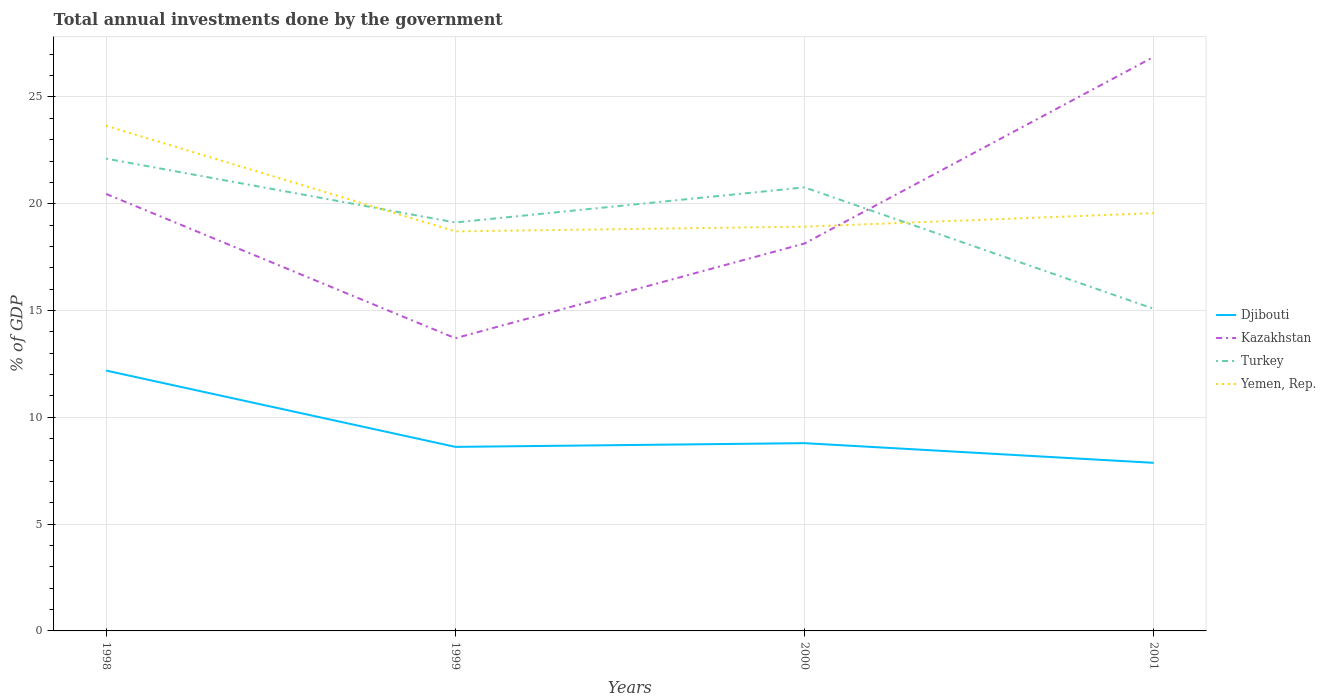How many different coloured lines are there?
Provide a short and direct response. 4. Does the line corresponding to Kazakhstan intersect with the line corresponding to Djibouti?
Your answer should be compact. No. Across all years, what is the maximum total annual investments done by the government in Yemen, Rep.?
Offer a terse response. 18.71. In which year was the total annual investments done by the government in Kazakhstan maximum?
Your answer should be very brief. 1999. What is the total total annual investments done by the government in Turkey in the graph?
Keep it short and to the point. 1.35. What is the difference between the highest and the second highest total annual investments done by the government in Yemen, Rep.?
Your answer should be very brief. 4.94. How many years are there in the graph?
Offer a terse response. 4. Are the values on the major ticks of Y-axis written in scientific E-notation?
Offer a terse response. No. How many legend labels are there?
Ensure brevity in your answer.  4. What is the title of the graph?
Ensure brevity in your answer.  Total annual investments done by the government. Does "Saudi Arabia" appear as one of the legend labels in the graph?
Your answer should be compact. No. What is the label or title of the Y-axis?
Offer a terse response. % of GDP. What is the % of GDP in Djibouti in 1998?
Provide a succinct answer. 12.19. What is the % of GDP in Kazakhstan in 1998?
Your answer should be compact. 20.46. What is the % of GDP of Turkey in 1998?
Your answer should be very brief. 22.11. What is the % of GDP in Yemen, Rep. in 1998?
Ensure brevity in your answer.  23.65. What is the % of GDP of Djibouti in 1999?
Keep it short and to the point. 8.62. What is the % of GDP of Kazakhstan in 1999?
Your response must be concise. 13.7. What is the % of GDP of Turkey in 1999?
Give a very brief answer. 19.12. What is the % of GDP in Yemen, Rep. in 1999?
Ensure brevity in your answer.  18.71. What is the % of GDP in Djibouti in 2000?
Ensure brevity in your answer.  8.79. What is the % of GDP in Kazakhstan in 2000?
Keep it short and to the point. 18.14. What is the % of GDP in Turkey in 2000?
Offer a terse response. 20.77. What is the % of GDP in Yemen, Rep. in 2000?
Give a very brief answer. 18.93. What is the % of GDP of Djibouti in 2001?
Offer a terse response. 7.87. What is the % of GDP in Kazakhstan in 2001?
Keep it short and to the point. 26.88. What is the % of GDP of Turkey in 2001?
Keep it short and to the point. 15.08. What is the % of GDP of Yemen, Rep. in 2001?
Provide a short and direct response. 19.56. Across all years, what is the maximum % of GDP of Djibouti?
Ensure brevity in your answer.  12.19. Across all years, what is the maximum % of GDP of Kazakhstan?
Offer a very short reply. 26.88. Across all years, what is the maximum % of GDP of Turkey?
Offer a very short reply. 22.11. Across all years, what is the maximum % of GDP in Yemen, Rep.?
Provide a succinct answer. 23.65. Across all years, what is the minimum % of GDP of Djibouti?
Keep it short and to the point. 7.87. Across all years, what is the minimum % of GDP of Kazakhstan?
Offer a very short reply. 13.7. Across all years, what is the minimum % of GDP in Turkey?
Your answer should be very brief. 15.08. Across all years, what is the minimum % of GDP of Yemen, Rep.?
Give a very brief answer. 18.71. What is the total % of GDP of Djibouti in the graph?
Ensure brevity in your answer.  37.47. What is the total % of GDP in Kazakhstan in the graph?
Offer a very short reply. 79.18. What is the total % of GDP in Turkey in the graph?
Ensure brevity in your answer.  77.09. What is the total % of GDP in Yemen, Rep. in the graph?
Provide a succinct answer. 80.84. What is the difference between the % of GDP in Djibouti in 1998 and that in 1999?
Keep it short and to the point. 3.57. What is the difference between the % of GDP of Kazakhstan in 1998 and that in 1999?
Ensure brevity in your answer.  6.76. What is the difference between the % of GDP of Turkey in 1998 and that in 1999?
Your answer should be compact. 2.99. What is the difference between the % of GDP in Yemen, Rep. in 1998 and that in 1999?
Provide a short and direct response. 4.94. What is the difference between the % of GDP in Djibouti in 1998 and that in 2000?
Your answer should be very brief. 3.4. What is the difference between the % of GDP in Kazakhstan in 1998 and that in 2000?
Provide a short and direct response. 2.32. What is the difference between the % of GDP in Turkey in 1998 and that in 2000?
Provide a succinct answer. 1.35. What is the difference between the % of GDP in Yemen, Rep. in 1998 and that in 2000?
Your response must be concise. 4.72. What is the difference between the % of GDP of Djibouti in 1998 and that in 2001?
Your response must be concise. 4.32. What is the difference between the % of GDP of Kazakhstan in 1998 and that in 2001?
Your answer should be compact. -6.42. What is the difference between the % of GDP in Turkey in 1998 and that in 2001?
Your answer should be compact. 7.03. What is the difference between the % of GDP of Yemen, Rep. in 1998 and that in 2001?
Provide a succinct answer. 4.09. What is the difference between the % of GDP in Djibouti in 1999 and that in 2000?
Offer a very short reply. -0.17. What is the difference between the % of GDP of Kazakhstan in 1999 and that in 2000?
Your answer should be very brief. -4.43. What is the difference between the % of GDP in Turkey in 1999 and that in 2000?
Your answer should be compact. -1.64. What is the difference between the % of GDP of Yemen, Rep. in 1999 and that in 2000?
Keep it short and to the point. -0.22. What is the difference between the % of GDP in Djibouti in 1999 and that in 2001?
Your response must be concise. 0.75. What is the difference between the % of GDP in Kazakhstan in 1999 and that in 2001?
Your answer should be very brief. -13.17. What is the difference between the % of GDP of Turkey in 1999 and that in 2001?
Provide a short and direct response. 4.04. What is the difference between the % of GDP of Yemen, Rep. in 1999 and that in 2001?
Your answer should be compact. -0.85. What is the difference between the % of GDP of Djibouti in 2000 and that in 2001?
Provide a succinct answer. 0.92. What is the difference between the % of GDP of Kazakhstan in 2000 and that in 2001?
Your response must be concise. -8.74. What is the difference between the % of GDP of Turkey in 2000 and that in 2001?
Keep it short and to the point. 5.68. What is the difference between the % of GDP of Yemen, Rep. in 2000 and that in 2001?
Give a very brief answer. -0.63. What is the difference between the % of GDP in Djibouti in 1998 and the % of GDP in Kazakhstan in 1999?
Provide a succinct answer. -1.51. What is the difference between the % of GDP of Djibouti in 1998 and the % of GDP of Turkey in 1999?
Your answer should be very brief. -6.93. What is the difference between the % of GDP of Djibouti in 1998 and the % of GDP of Yemen, Rep. in 1999?
Provide a short and direct response. -6.52. What is the difference between the % of GDP of Kazakhstan in 1998 and the % of GDP of Turkey in 1999?
Provide a short and direct response. 1.34. What is the difference between the % of GDP of Kazakhstan in 1998 and the % of GDP of Yemen, Rep. in 1999?
Your response must be concise. 1.75. What is the difference between the % of GDP in Turkey in 1998 and the % of GDP in Yemen, Rep. in 1999?
Make the answer very short. 3.41. What is the difference between the % of GDP of Djibouti in 1998 and the % of GDP of Kazakhstan in 2000?
Offer a very short reply. -5.95. What is the difference between the % of GDP of Djibouti in 1998 and the % of GDP of Turkey in 2000?
Your response must be concise. -8.58. What is the difference between the % of GDP of Djibouti in 1998 and the % of GDP of Yemen, Rep. in 2000?
Your response must be concise. -6.74. What is the difference between the % of GDP in Kazakhstan in 1998 and the % of GDP in Turkey in 2000?
Provide a short and direct response. -0.31. What is the difference between the % of GDP in Kazakhstan in 1998 and the % of GDP in Yemen, Rep. in 2000?
Your response must be concise. 1.53. What is the difference between the % of GDP of Turkey in 1998 and the % of GDP of Yemen, Rep. in 2000?
Make the answer very short. 3.19. What is the difference between the % of GDP in Djibouti in 1998 and the % of GDP in Kazakhstan in 2001?
Your answer should be compact. -14.69. What is the difference between the % of GDP in Djibouti in 1998 and the % of GDP in Turkey in 2001?
Provide a short and direct response. -2.89. What is the difference between the % of GDP in Djibouti in 1998 and the % of GDP in Yemen, Rep. in 2001?
Offer a terse response. -7.37. What is the difference between the % of GDP of Kazakhstan in 1998 and the % of GDP of Turkey in 2001?
Your response must be concise. 5.38. What is the difference between the % of GDP in Kazakhstan in 1998 and the % of GDP in Yemen, Rep. in 2001?
Provide a short and direct response. 0.9. What is the difference between the % of GDP in Turkey in 1998 and the % of GDP in Yemen, Rep. in 2001?
Offer a very short reply. 2.55. What is the difference between the % of GDP of Djibouti in 1999 and the % of GDP of Kazakhstan in 2000?
Provide a succinct answer. -9.52. What is the difference between the % of GDP of Djibouti in 1999 and the % of GDP of Turkey in 2000?
Your answer should be compact. -12.15. What is the difference between the % of GDP in Djibouti in 1999 and the % of GDP in Yemen, Rep. in 2000?
Offer a very short reply. -10.31. What is the difference between the % of GDP in Kazakhstan in 1999 and the % of GDP in Turkey in 2000?
Offer a terse response. -7.06. What is the difference between the % of GDP of Kazakhstan in 1999 and the % of GDP of Yemen, Rep. in 2000?
Ensure brevity in your answer.  -5.22. What is the difference between the % of GDP of Turkey in 1999 and the % of GDP of Yemen, Rep. in 2000?
Your response must be concise. 0.2. What is the difference between the % of GDP of Djibouti in 1999 and the % of GDP of Kazakhstan in 2001?
Your answer should be compact. -18.26. What is the difference between the % of GDP of Djibouti in 1999 and the % of GDP of Turkey in 2001?
Make the answer very short. -6.47. What is the difference between the % of GDP in Djibouti in 1999 and the % of GDP in Yemen, Rep. in 2001?
Provide a short and direct response. -10.94. What is the difference between the % of GDP of Kazakhstan in 1999 and the % of GDP of Turkey in 2001?
Give a very brief answer. -1.38. What is the difference between the % of GDP in Kazakhstan in 1999 and the % of GDP in Yemen, Rep. in 2001?
Keep it short and to the point. -5.86. What is the difference between the % of GDP in Turkey in 1999 and the % of GDP in Yemen, Rep. in 2001?
Your response must be concise. -0.44. What is the difference between the % of GDP of Djibouti in 2000 and the % of GDP of Kazakhstan in 2001?
Ensure brevity in your answer.  -18.09. What is the difference between the % of GDP of Djibouti in 2000 and the % of GDP of Turkey in 2001?
Your answer should be compact. -6.29. What is the difference between the % of GDP of Djibouti in 2000 and the % of GDP of Yemen, Rep. in 2001?
Make the answer very short. -10.77. What is the difference between the % of GDP of Kazakhstan in 2000 and the % of GDP of Turkey in 2001?
Offer a very short reply. 3.06. What is the difference between the % of GDP of Kazakhstan in 2000 and the % of GDP of Yemen, Rep. in 2001?
Give a very brief answer. -1.42. What is the difference between the % of GDP in Turkey in 2000 and the % of GDP in Yemen, Rep. in 2001?
Give a very brief answer. 1.21. What is the average % of GDP of Djibouti per year?
Offer a terse response. 9.37. What is the average % of GDP of Kazakhstan per year?
Make the answer very short. 19.8. What is the average % of GDP of Turkey per year?
Provide a succinct answer. 19.27. What is the average % of GDP in Yemen, Rep. per year?
Offer a terse response. 20.21. In the year 1998, what is the difference between the % of GDP of Djibouti and % of GDP of Kazakhstan?
Your answer should be compact. -8.27. In the year 1998, what is the difference between the % of GDP of Djibouti and % of GDP of Turkey?
Your response must be concise. -9.92. In the year 1998, what is the difference between the % of GDP of Djibouti and % of GDP of Yemen, Rep.?
Offer a terse response. -11.46. In the year 1998, what is the difference between the % of GDP in Kazakhstan and % of GDP in Turkey?
Ensure brevity in your answer.  -1.65. In the year 1998, what is the difference between the % of GDP in Kazakhstan and % of GDP in Yemen, Rep.?
Keep it short and to the point. -3.19. In the year 1998, what is the difference between the % of GDP in Turkey and % of GDP in Yemen, Rep.?
Offer a terse response. -1.54. In the year 1999, what is the difference between the % of GDP in Djibouti and % of GDP in Kazakhstan?
Provide a succinct answer. -5.09. In the year 1999, what is the difference between the % of GDP in Djibouti and % of GDP in Turkey?
Make the answer very short. -10.51. In the year 1999, what is the difference between the % of GDP in Djibouti and % of GDP in Yemen, Rep.?
Provide a succinct answer. -10.09. In the year 1999, what is the difference between the % of GDP in Kazakhstan and % of GDP in Turkey?
Make the answer very short. -5.42. In the year 1999, what is the difference between the % of GDP in Kazakhstan and % of GDP in Yemen, Rep.?
Your response must be concise. -5. In the year 1999, what is the difference between the % of GDP of Turkey and % of GDP of Yemen, Rep.?
Ensure brevity in your answer.  0.42. In the year 2000, what is the difference between the % of GDP in Djibouti and % of GDP in Kazakhstan?
Ensure brevity in your answer.  -9.35. In the year 2000, what is the difference between the % of GDP of Djibouti and % of GDP of Turkey?
Offer a very short reply. -11.98. In the year 2000, what is the difference between the % of GDP of Djibouti and % of GDP of Yemen, Rep.?
Give a very brief answer. -10.14. In the year 2000, what is the difference between the % of GDP in Kazakhstan and % of GDP in Turkey?
Provide a short and direct response. -2.63. In the year 2000, what is the difference between the % of GDP in Kazakhstan and % of GDP in Yemen, Rep.?
Give a very brief answer. -0.79. In the year 2000, what is the difference between the % of GDP of Turkey and % of GDP of Yemen, Rep.?
Offer a terse response. 1.84. In the year 2001, what is the difference between the % of GDP in Djibouti and % of GDP in Kazakhstan?
Give a very brief answer. -19.01. In the year 2001, what is the difference between the % of GDP in Djibouti and % of GDP in Turkey?
Your response must be concise. -7.21. In the year 2001, what is the difference between the % of GDP of Djibouti and % of GDP of Yemen, Rep.?
Offer a very short reply. -11.69. In the year 2001, what is the difference between the % of GDP in Kazakhstan and % of GDP in Turkey?
Ensure brevity in your answer.  11.79. In the year 2001, what is the difference between the % of GDP of Kazakhstan and % of GDP of Yemen, Rep.?
Offer a terse response. 7.32. In the year 2001, what is the difference between the % of GDP in Turkey and % of GDP in Yemen, Rep.?
Offer a very short reply. -4.48. What is the ratio of the % of GDP of Djibouti in 1998 to that in 1999?
Your response must be concise. 1.41. What is the ratio of the % of GDP of Kazakhstan in 1998 to that in 1999?
Your answer should be compact. 1.49. What is the ratio of the % of GDP in Turkey in 1998 to that in 1999?
Give a very brief answer. 1.16. What is the ratio of the % of GDP in Yemen, Rep. in 1998 to that in 1999?
Ensure brevity in your answer.  1.26. What is the ratio of the % of GDP of Djibouti in 1998 to that in 2000?
Give a very brief answer. 1.39. What is the ratio of the % of GDP in Kazakhstan in 1998 to that in 2000?
Provide a succinct answer. 1.13. What is the ratio of the % of GDP of Turkey in 1998 to that in 2000?
Provide a succinct answer. 1.06. What is the ratio of the % of GDP in Yemen, Rep. in 1998 to that in 2000?
Ensure brevity in your answer.  1.25. What is the ratio of the % of GDP in Djibouti in 1998 to that in 2001?
Give a very brief answer. 1.55. What is the ratio of the % of GDP of Kazakhstan in 1998 to that in 2001?
Provide a short and direct response. 0.76. What is the ratio of the % of GDP of Turkey in 1998 to that in 2001?
Your response must be concise. 1.47. What is the ratio of the % of GDP of Yemen, Rep. in 1998 to that in 2001?
Ensure brevity in your answer.  1.21. What is the ratio of the % of GDP in Djibouti in 1999 to that in 2000?
Your response must be concise. 0.98. What is the ratio of the % of GDP of Kazakhstan in 1999 to that in 2000?
Your answer should be compact. 0.76. What is the ratio of the % of GDP in Turkey in 1999 to that in 2000?
Your response must be concise. 0.92. What is the ratio of the % of GDP of Yemen, Rep. in 1999 to that in 2000?
Ensure brevity in your answer.  0.99. What is the ratio of the % of GDP in Djibouti in 1999 to that in 2001?
Offer a very short reply. 1.09. What is the ratio of the % of GDP in Kazakhstan in 1999 to that in 2001?
Provide a succinct answer. 0.51. What is the ratio of the % of GDP in Turkey in 1999 to that in 2001?
Your answer should be compact. 1.27. What is the ratio of the % of GDP of Yemen, Rep. in 1999 to that in 2001?
Provide a short and direct response. 0.96. What is the ratio of the % of GDP of Djibouti in 2000 to that in 2001?
Provide a succinct answer. 1.12. What is the ratio of the % of GDP of Kazakhstan in 2000 to that in 2001?
Make the answer very short. 0.67. What is the ratio of the % of GDP of Turkey in 2000 to that in 2001?
Provide a short and direct response. 1.38. What is the difference between the highest and the second highest % of GDP in Djibouti?
Provide a succinct answer. 3.4. What is the difference between the highest and the second highest % of GDP in Kazakhstan?
Offer a very short reply. 6.42. What is the difference between the highest and the second highest % of GDP in Turkey?
Give a very brief answer. 1.35. What is the difference between the highest and the second highest % of GDP of Yemen, Rep.?
Offer a very short reply. 4.09. What is the difference between the highest and the lowest % of GDP in Djibouti?
Your answer should be compact. 4.32. What is the difference between the highest and the lowest % of GDP of Kazakhstan?
Your response must be concise. 13.17. What is the difference between the highest and the lowest % of GDP of Turkey?
Offer a very short reply. 7.03. What is the difference between the highest and the lowest % of GDP of Yemen, Rep.?
Your answer should be compact. 4.94. 